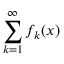<formula> <loc_0><loc_0><loc_500><loc_500>\sum _ { k = 1 } ^ { \infty } f _ { k } ( x )</formula> 